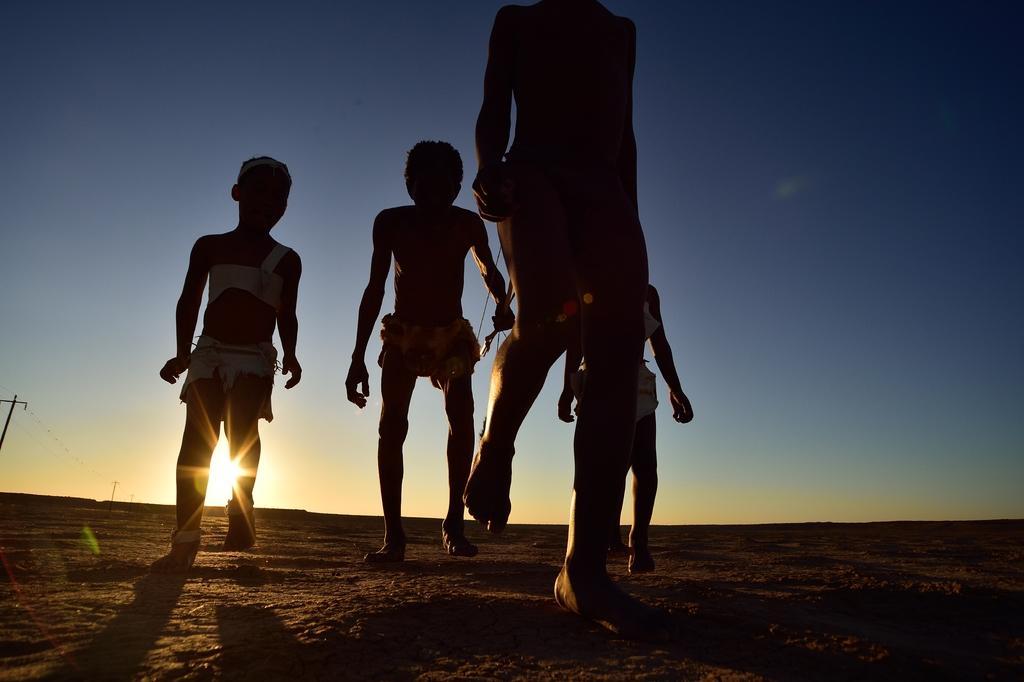In one or two sentences, can you explain what this image depicts? In this image we can see there are people walking on the ground. And at the back we can see current pole and the sky. 